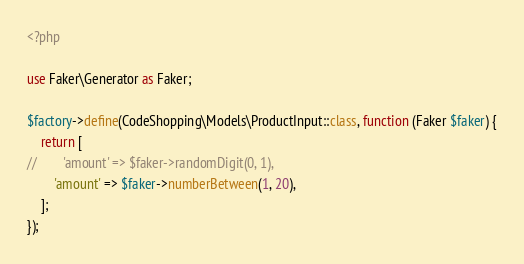Convert code to text. <code><loc_0><loc_0><loc_500><loc_500><_PHP_><?php

use Faker\Generator as Faker;

$factory->define(CodeShopping\Models\ProductInput::class, function (Faker $faker) {
    return [
//        'amount' => $faker->randomDigit(0, 1),
        'amount' => $faker->numberBetween(1, 20),
    ];
});
</code> 